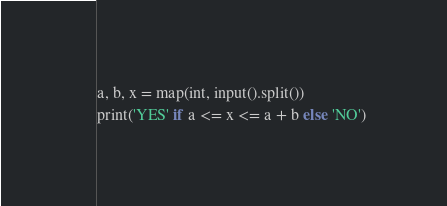<code> <loc_0><loc_0><loc_500><loc_500><_Python_>a, b, x = map(int, input().split())
print('YES' if a <= x <= a + b else 'NO')</code> 